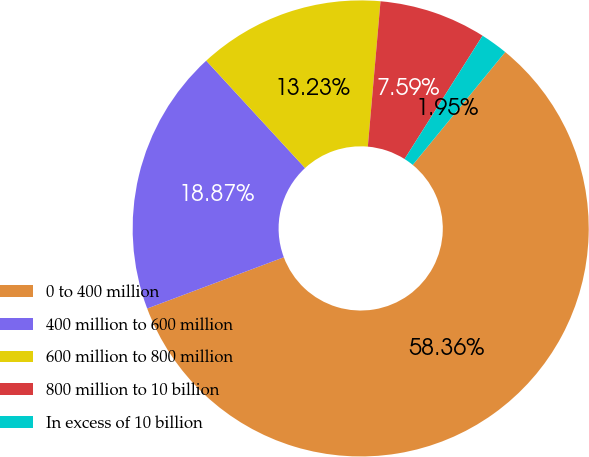<chart> <loc_0><loc_0><loc_500><loc_500><pie_chart><fcel>0 to 400 million<fcel>400 million to 600 million<fcel>600 million to 800 million<fcel>800 million to 10 billion<fcel>In excess of 10 billion<nl><fcel>58.37%<fcel>18.87%<fcel>13.23%<fcel>7.59%<fcel>1.95%<nl></chart> 